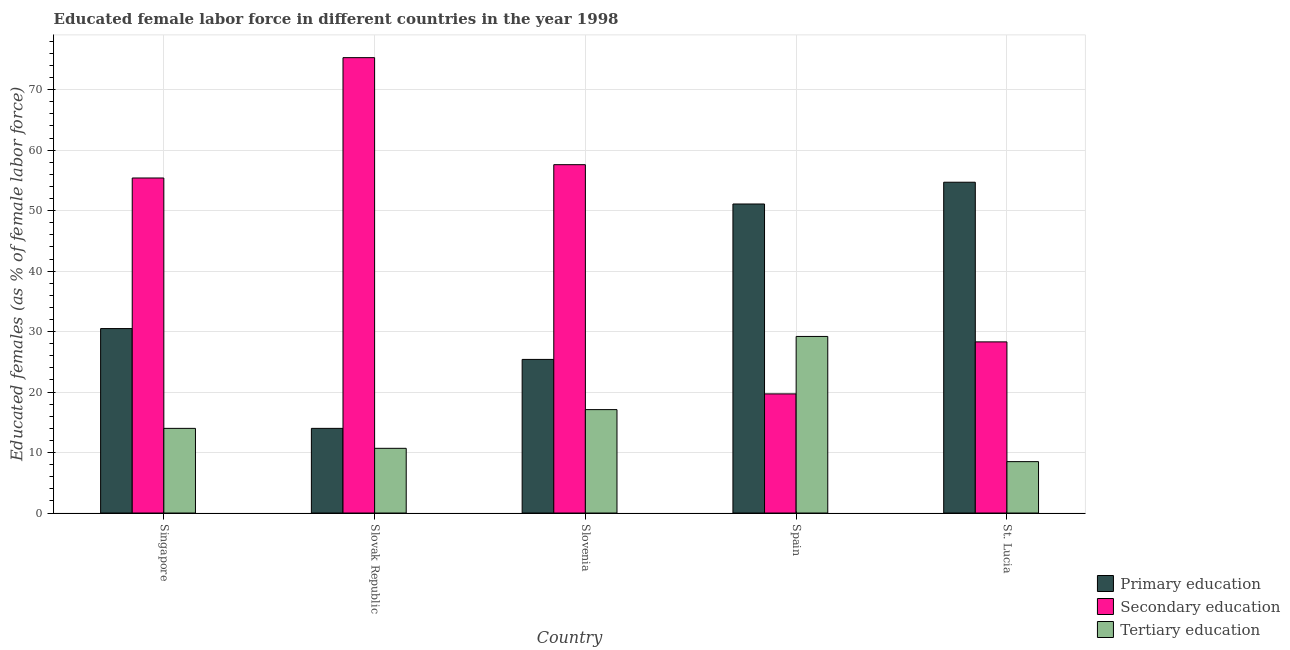How many groups of bars are there?
Your answer should be very brief. 5. Are the number of bars on each tick of the X-axis equal?
Offer a terse response. Yes. How many bars are there on the 5th tick from the right?
Your answer should be compact. 3. What is the label of the 2nd group of bars from the left?
Offer a terse response. Slovak Republic. In how many cases, is the number of bars for a given country not equal to the number of legend labels?
Make the answer very short. 0. What is the percentage of female labor force who received secondary education in St. Lucia?
Your answer should be compact. 28.3. Across all countries, what is the maximum percentage of female labor force who received primary education?
Offer a terse response. 54.7. Across all countries, what is the minimum percentage of female labor force who received primary education?
Your answer should be compact. 14. In which country was the percentage of female labor force who received primary education maximum?
Ensure brevity in your answer.  St. Lucia. In which country was the percentage of female labor force who received tertiary education minimum?
Keep it short and to the point. St. Lucia. What is the total percentage of female labor force who received primary education in the graph?
Offer a terse response. 175.7. What is the difference between the percentage of female labor force who received tertiary education in Slovak Republic and that in Slovenia?
Your answer should be compact. -6.4. What is the difference between the percentage of female labor force who received secondary education in Slovak Republic and the percentage of female labor force who received tertiary education in Spain?
Keep it short and to the point. 46.1. What is the average percentage of female labor force who received secondary education per country?
Ensure brevity in your answer.  47.26. What is the difference between the percentage of female labor force who received tertiary education and percentage of female labor force who received primary education in Slovak Republic?
Provide a short and direct response. -3.3. In how many countries, is the percentage of female labor force who received secondary education greater than 62 %?
Your answer should be compact. 1. What is the ratio of the percentage of female labor force who received secondary education in Slovenia to that in Spain?
Your answer should be very brief. 2.92. Is the percentage of female labor force who received tertiary education in Spain less than that in St. Lucia?
Make the answer very short. No. Is the difference between the percentage of female labor force who received secondary education in Slovak Republic and Slovenia greater than the difference between the percentage of female labor force who received tertiary education in Slovak Republic and Slovenia?
Your response must be concise. Yes. What is the difference between the highest and the second highest percentage of female labor force who received primary education?
Your response must be concise. 3.6. What is the difference between the highest and the lowest percentage of female labor force who received secondary education?
Keep it short and to the point. 55.6. In how many countries, is the percentage of female labor force who received primary education greater than the average percentage of female labor force who received primary education taken over all countries?
Your response must be concise. 2. What does the 3rd bar from the left in Slovak Republic represents?
Provide a short and direct response. Tertiary education. What does the 1st bar from the right in Slovenia represents?
Provide a succinct answer. Tertiary education. Is it the case that in every country, the sum of the percentage of female labor force who received primary education and percentage of female labor force who received secondary education is greater than the percentage of female labor force who received tertiary education?
Make the answer very short. Yes. How many bars are there?
Your answer should be compact. 15. What is the difference between two consecutive major ticks on the Y-axis?
Ensure brevity in your answer.  10. Does the graph contain grids?
Keep it short and to the point. Yes. How are the legend labels stacked?
Provide a short and direct response. Vertical. What is the title of the graph?
Give a very brief answer. Educated female labor force in different countries in the year 1998. What is the label or title of the Y-axis?
Offer a terse response. Educated females (as % of female labor force). What is the Educated females (as % of female labor force) of Primary education in Singapore?
Offer a terse response. 30.5. What is the Educated females (as % of female labor force) in Secondary education in Singapore?
Offer a very short reply. 55.4. What is the Educated females (as % of female labor force) in Primary education in Slovak Republic?
Offer a terse response. 14. What is the Educated females (as % of female labor force) in Secondary education in Slovak Republic?
Your response must be concise. 75.3. What is the Educated females (as % of female labor force) of Tertiary education in Slovak Republic?
Provide a short and direct response. 10.7. What is the Educated females (as % of female labor force) in Primary education in Slovenia?
Your answer should be compact. 25.4. What is the Educated females (as % of female labor force) in Secondary education in Slovenia?
Ensure brevity in your answer.  57.6. What is the Educated females (as % of female labor force) of Tertiary education in Slovenia?
Your answer should be compact. 17.1. What is the Educated females (as % of female labor force) in Primary education in Spain?
Give a very brief answer. 51.1. What is the Educated females (as % of female labor force) in Secondary education in Spain?
Keep it short and to the point. 19.7. What is the Educated females (as % of female labor force) of Tertiary education in Spain?
Offer a very short reply. 29.2. What is the Educated females (as % of female labor force) of Primary education in St. Lucia?
Make the answer very short. 54.7. What is the Educated females (as % of female labor force) in Secondary education in St. Lucia?
Your response must be concise. 28.3. Across all countries, what is the maximum Educated females (as % of female labor force) of Primary education?
Give a very brief answer. 54.7. Across all countries, what is the maximum Educated females (as % of female labor force) of Secondary education?
Your answer should be compact. 75.3. Across all countries, what is the maximum Educated females (as % of female labor force) in Tertiary education?
Offer a terse response. 29.2. Across all countries, what is the minimum Educated females (as % of female labor force) in Primary education?
Keep it short and to the point. 14. Across all countries, what is the minimum Educated females (as % of female labor force) of Secondary education?
Give a very brief answer. 19.7. Across all countries, what is the minimum Educated females (as % of female labor force) in Tertiary education?
Offer a very short reply. 8.5. What is the total Educated females (as % of female labor force) in Primary education in the graph?
Offer a very short reply. 175.7. What is the total Educated females (as % of female labor force) of Secondary education in the graph?
Offer a terse response. 236.3. What is the total Educated females (as % of female labor force) of Tertiary education in the graph?
Your answer should be very brief. 79.5. What is the difference between the Educated females (as % of female labor force) of Primary education in Singapore and that in Slovak Republic?
Provide a short and direct response. 16.5. What is the difference between the Educated females (as % of female labor force) of Secondary education in Singapore and that in Slovak Republic?
Make the answer very short. -19.9. What is the difference between the Educated females (as % of female labor force) in Tertiary education in Singapore and that in Slovak Republic?
Your answer should be compact. 3.3. What is the difference between the Educated females (as % of female labor force) of Primary education in Singapore and that in Slovenia?
Provide a succinct answer. 5.1. What is the difference between the Educated females (as % of female labor force) of Secondary education in Singapore and that in Slovenia?
Keep it short and to the point. -2.2. What is the difference between the Educated females (as % of female labor force) of Primary education in Singapore and that in Spain?
Your response must be concise. -20.6. What is the difference between the Educated females (as % of female labor force) in Secondary education in Singapore and that in Spain?
Your response must be concise. 35.7. What is the difference between the Educated females (as % of female labor force) in Tertiary education in Singapore and that in Spain?
Your response must be concise. -15.2. What is the difference between the Educated females (as % of female labor force) of Primary education in Singapore and that in St. Lucia?
Make the answer very short. -24.2. What is the difference between the Educated females (as % of female labor force) in Secondary education in Singapore and that in St. Lucia?
Ensure brevity in your answer.  27.1. What is the difference between the Educated females (as % of female labor force) in Secondary education in Slovak Republic and that in Slovenia?
Keep it short and to the point. 17.7. What is the difference between the Educated females (as % of female labor force) in Tertiary education in Slovak Republic and that in Slovenia?
Provide a short and direct response. -6.4. What is the difference between the Educated females (as % of female labor force) of Primary education in Slovak Republic and that in Spain?
Offer a terse response. -37.1. What is the difference between the Educated females (as % of female labor force) of Secondary education in Slovak Republic and that in Spain?
Your answer should be very brief. 55.6. What is the difference between the Educated females (as % of female labor force) of Tertiary education in Slovak Republic and that in Spain?
Give a very brief answer. -18.5. What is the difference between the Educated females (as % of female labor force) in Primary education in Slovak Republic and that in St. Lucia?
Provide a succinct answer. -40.7. What is the difference between the Educated females (as % of female labor force) of Secondary education in Slovak Republic and that in St. Lucia?
Your answer should be very brief. 47. What is the difference between the Educated females (as % of female labor force) of Tertiary education in Slovak Republic and that in St. Lucia?
Give a very brief answer. 2.2. What is the difference between the Educated females (as % of female labor force) in Primary education in Slovenia and that in Spain?
Offer a very short reply. -25.7. What is the difference between the Educated females (as % of female labor force) of Secondary education in Slovenia and that in Spain?
Provide a short and direct response. 37.9. What is the difference between the Educated females (as % of female labor force) in Tertiary education in Slovenia and that in Spain?
Your answer should be very brief. -12.1. What is the difference between the Educated females (as % of female labor force) in Primary education in Slovenia and that in St. Lucia?
Offer a very short reply. -29.3. What is the difference between the Educated females (as % of female labor force) in Secondary education in Slovenia and that in St. Lucia?
Provide a short and direct response. 29.3. What is the difference between the Educated females (as % of female labor force) of Tertiary education in Spain and that in St. Lucia?
Make the answer very short. 20.7. What is the difference between the Educated females (as % of female labor force) in Primary education in Singapore and the Educated females (as % of female labor force) in Secondary education in Slovak Republic?
Offer a terse response. -44.8. What is the difference between the Educated females (as % of female labor force) of Primary education in Singapore and the Educated females (as % of female labor force) of Tertiary education in Slovak Republic?
Give a very brief answer. 19.8. What is the difference between the Educated females (as % of female labor force) of Secondary education in Singapore and the Educated females (as % of female labor force) of Tertiary education in Slovak Republic?
Keep it short and to the point. 44.7. What is the difference between the Educated females (as % of female labor force) of Primary education in Singapore and the Educated females (as % of female labor force) of Secondary education in Slovenia?
Keep it short and to the point. -27.1. What is the difference between the Educated females (as % of female labor force) in Secondary education in Singapore and the Educated females (as % of female labor force) in Tertiary education in Slovenia?
Ensure brevity in your answer.  38.3. What is the difference between the Educated females (as % of female labor force) of Secondary education in Singapore and the Educated females (as % of female labor force) of Tertiary education in Spain?
Keep it short and to the point. 26.2. What is the difference between the Educated females (as % of female labor force) of Primary education in Singapore and the Educated females (as % of female labor force) of Secondary education in St. Lucia?
Your answer should be compact. 2.2. What is the difference between the Educated females (as % of female labor force) in Secondary education in Singapore and the Educated females (as % of female labor force) in Tertiary education in St. Lucia?
Your answer should be very brief. 46.9. What is the difference between the Educated females (as % of female labor force) of Primary education in Slovak Republic and the Educated females (as % of female labor force) of Secondary education in Slovenia?
Your answer should be very brief. -43.6. What is the difference between the Educated females (as % of female labor force) in Secondary education in Slovak Republic and the Educated females (as % of female labor force) in Tertiary education in Slovenia?
Provide a succinct answer. 58.2. What is the difference between the Educated females (as % of female labor force) in Primary education in Slovak Republic and the Educated females (as % of female labor force) in Secondary education in Spain?
Make the answer very short. -5.7. What is the difference between the Educated females (as % of female labor force) in Primary education in Slovak Republic and the Educated females (as % of female labor force) in Tertiary education in Spain?
Your answer should be compact. -15.2. What is the difference between the Educated females (as % of female labor force) in Secondary education in Slovak Republic and the Educated females (as % of female labor force) in Tertiary education in Spain?
Your response must be concise. 46.1. What is the difference between the Educated females (as % of female labor force) of Primary education in Slovak Republic and the Educated females (as % of female labor force) of Secondary education in St. Lucia?
Your answer should be compact. -14.3. What is the difference between the Educated females (as % of female labor force) in Primary education in Slovak Republic and the Educated females (as % of female labor force) in Tertiary education in St. Lucia?
Give a very brief answer. 5.5. What is the difference between the Educated females (as % of female labor force) in Secondary education in Slovak Republic and the Educated females (as % of female labor force) in Tertiary education in St. Lucia?
Ensure brevity in your answer.  66.8. What is the difference between the Educated females (as % of female labor force) in Secondary education in Slovenia and the Educated females (as % of female labor force) in Tertiary education in Spain?
Keep it short and to the point. 28.4. What is the difference between the Educated females (as % of female labor force) in Primary education in Slovenia and the Educated females (as % of female labor force) in Secondary education in St. Lucia?
Give a very brief answer. -2.9. What is the difference between the Educated females (as % of female labor force) of Secondary education in Slovenia and the Educated females (as % of female labor force) of Tertiary education in St. Lucia?
Make the answer very short. 49.1. What is the difference between the Educated females (as % of female labor force) in Primary education in Spain and the Educated females (as % of female labor force) in Secondary education in St. Lucia?
Ensure brevity in your answer.  22.8. What is the difference between the Educated females (as % of female labor force) in Primary education in Spain and the Educated females (as % of female labor force) in Tertiary education in St. Lucia?
Your answer should be compact. 42.6. What is the average Educated females (as % of female labor force) of Primary education per country?
Provide a short and direct response. 35.14. What is the average Educated females (as % of female labor force) in Secondary education per country?
Your response must be concise. 47.26. What is the difference between the Educated females (as % of female labor force) of Primary education and Educated females (as % of female labor force) of Secondary education in Singapore?
Your answer should be compact. -24.9. What is the difference between the Educated females (as % of female labor force) in Primary education and Educated females (as % of female labor force) in Tertiary education in Singapore?
Your answer should be compact. 16.5. What is the difference between the Educated females (as % of female labor force) of Secondary education and Educated females (as % of female labor force) of Tertiary education in Singapore?
Offer a very short reply. 41.4. What is the difference between the Educated females (as % of female labor force) in Primary education and Educated females (as % of female labor force) in Secondary education in Slovak Republic?
Make the answer very short. -61.3. What is the difference between the Educated females (as % of female labor force) of Primary education and Educated females (as % of female labor force) of Tertiary education in Slovak Republic?
Your answer should be very brief. 3.3. What is the difference between the Educated females (as % of female labor force) in Secondary education and Educated females (as % of female labor force) in Tertiary education in Slovak Republic?
Keep it short and to the point. 64.6. What is the difference between the Educated females (as % of female labor force) in Primary education and Educated females (as % of female labor force) in Secondary education in Slovenia?
Keep it short and to the point. -32.2. What is the difference between the Educated females (as % of female labor force) of Secondary education and Educated females (as % of female labor force) of Tertiary education in Slovenia?
Make the answer very short. 40.5. What is the difference between the Educated females (as % of female labor force) in Primary education and Educated females (as % of female labor force) in Secondary education in Spain?
Keep it short and to the point. 31.4. What is the difference between the Educated females (as % of female labor force) in Primary education and Educated females (as % of female labor force) in Tertiary education in Spain?
Ensure brevity in your answer.  21.9. What is the difference between the Educated females (as % of female labor force) of Secondary education and Educated females (as % of female labor force) of Tertiary education in Spain?
Provide a short and direct response. -9.5. What is the difference between the Educated females (as % of female labor force) in Primary education and Educated females (as % of female labor force) in Secondary education in St. Lucia?
Your answer should be very brief. 26.4. What is the difference between the Educated females (as % of female labor force) of Primary education and Educated females (as % of female labor force) of Tertiary education in St. Lucia?
Provide a succinct answer. 46.2. What is the difference between the Educated females (as % of female labor force) of Secondary education and Educated females (as % of female labor force) of Tertiary education in St. Lucia?
Give a very brief answer. 19.8. What is the ratio of the Educated females (as % of female labor force) in Primary education in Singapore to that in Slovak Republic?
Make the answer very short. 2.18. What is the ratio of the Educated females (as % of female labor force) in Secondary education in Singapore to that in Slovak Republic?
Offer a very short reply. 0.74. What is the ratio of the Educated females (as % of female labor force) of Tertiary education in Singapore to that in Slovak Republic?
Provide a succinct answer. 1.31. What is the ratio of the Educated females (as % of female labor force) of Primary education in Singapore to that in Slovenia?
Offer a terse response. 1.2. What is the ratio of the Educated females (as % of female labor force) of Secondary education in Singapore to that in Slovenia?
Provide a short and direct response. 0.96. What is the ratio of the Educated females (as % of female labor force) of Tertiary education in Singapore to that in Slovenia?
Make the answer very short. 0.82. What is the ratio of the Educated females (as % of female labor force) in Primary education in Singapore to that in Spain?
Offer a terse response. 0.6. What is the ratio of the Educated females (as % of female labor force) in Secondary education in Singapore to that in Spain?
Provide a succinct answer. 2.81. What is the ratio of the Educated females (as % of female labor force) of Tertiary education in Singapore to that in Spain?
Your answer should be very brief. 0.48. What is the ratio of the Educated females (as % of female labor force) of Primary education in Singapore to that in St. Lucia?
Your answer should be very brief. 0.56. What is the ratio of the Educated females (as % of female labor force) of Secondary education in Singapore to that in St. Lucia?
Make the answer very short. 1.96. What is the ratio of the Educated females (as % of female labor force) of Tertiary education in Singapore to that in St. Lucia?
Make the answer very short. 1.65. What is the ratio of the Educated females (as % of female labor force) in Primary education in Slovak Republic to that in Slovenia?
Offer a terse response. 0.55. What is the ratio of the Educated females (as % of female labor force) in Secondary education in Slovak Republic to that in Slovenia?
Offer a terse response. 1.31. What is the ratio of the Educated females (as % of female labor force) in Tertiary education in Slovak Republic to that in Slovenia?
Your answer should be very brief. 0.63. What is the ratio of the Educated females (as % of female labor force) in Primary education in Slovak Republic to that in Spain?
Your answer should be compact. 0.27. What is the ratio of the Educated females (as % of female labor force) in Secondary education in Slovak Republic to that in Spain?
Your answer should be compact. 3.82. What is the ratio of the Educated females (as % of female labor force) of Tertiary education in Slovak Republic to that in Spain?
Your answer should be compact. 0.37. What is the ratio of the Educated females (as % of female labor force) of Primary education in Slovak Republic to that in St. Lucia?
Provide a succinct answer. 0.26. What is the ratio of the Educated females (as % of female labor force) in Secondary education in Slovak Republic to that in St. Lucia?
Provide a succinct answer. 2.66. What is the ratio of the Educated females (as % of female labor force) of Tertiary education in Slovak Republic to that in St. Lucia?
Your answer should be compact. 1.26. What is the ratio of the Educated females (as % of female labor force) of Primary education in Slovenia to that in Spain?
Keep it short and to the point. 0.5. What is the ratio of the Educated females (as % of female labor force) of Secondary education in Slovenia to that in Spain?
Your response must be concise. 2.92. What is the ratio of the Educated females (as % of female labor force) of Tertiary education in Slovenia to that in Spain?
Ensure brevity in your answer.  0.59. What is the ratio of the Educated females (as % of female labor force) of Primary education in Slovenia to that in St. Lucia?
Your answer should be compact. 0.46. What is the ratio of the Educated females (as % of female labor force) of Secondary education in Slovenia to that in St. Lucia?
Your answer should be very brief. 2.04. What is the ratio of the Educated females (as % of female labor force) in Tertiary education in Slovenia to that in St. Lucia?
Make the answer very short. 2.01. What is the ratio of the Educated females (as % of female labor force) of Primary education in Spain to that in St. Lucia?
Ensure brevity in your answer.  0.93. What is the ratio of the Educated females (as % of female labor force) in Secondary education in Spain to that in St. Lucia?
Your answer should be compact. 0.7. What is the ratio of the Educated females (as % of female labor force) of Tertiary education in Spain to that in St. Lucia?
Make the answer very short. 3.44. What is the difference between the highest and the lowest Educated females (as % of female labor force) of Primary education?
Keep it short and to the point. 40.7. What is the difference between the highest and the lowest Educated females (as % of female labor force) of Secondary education?
Give a very brief answer. 55.6. What is the difference between the highest and the lowest Educated females (as % of female labor force) in Tertiary education?
Your answer should be very brief. 20.7. 